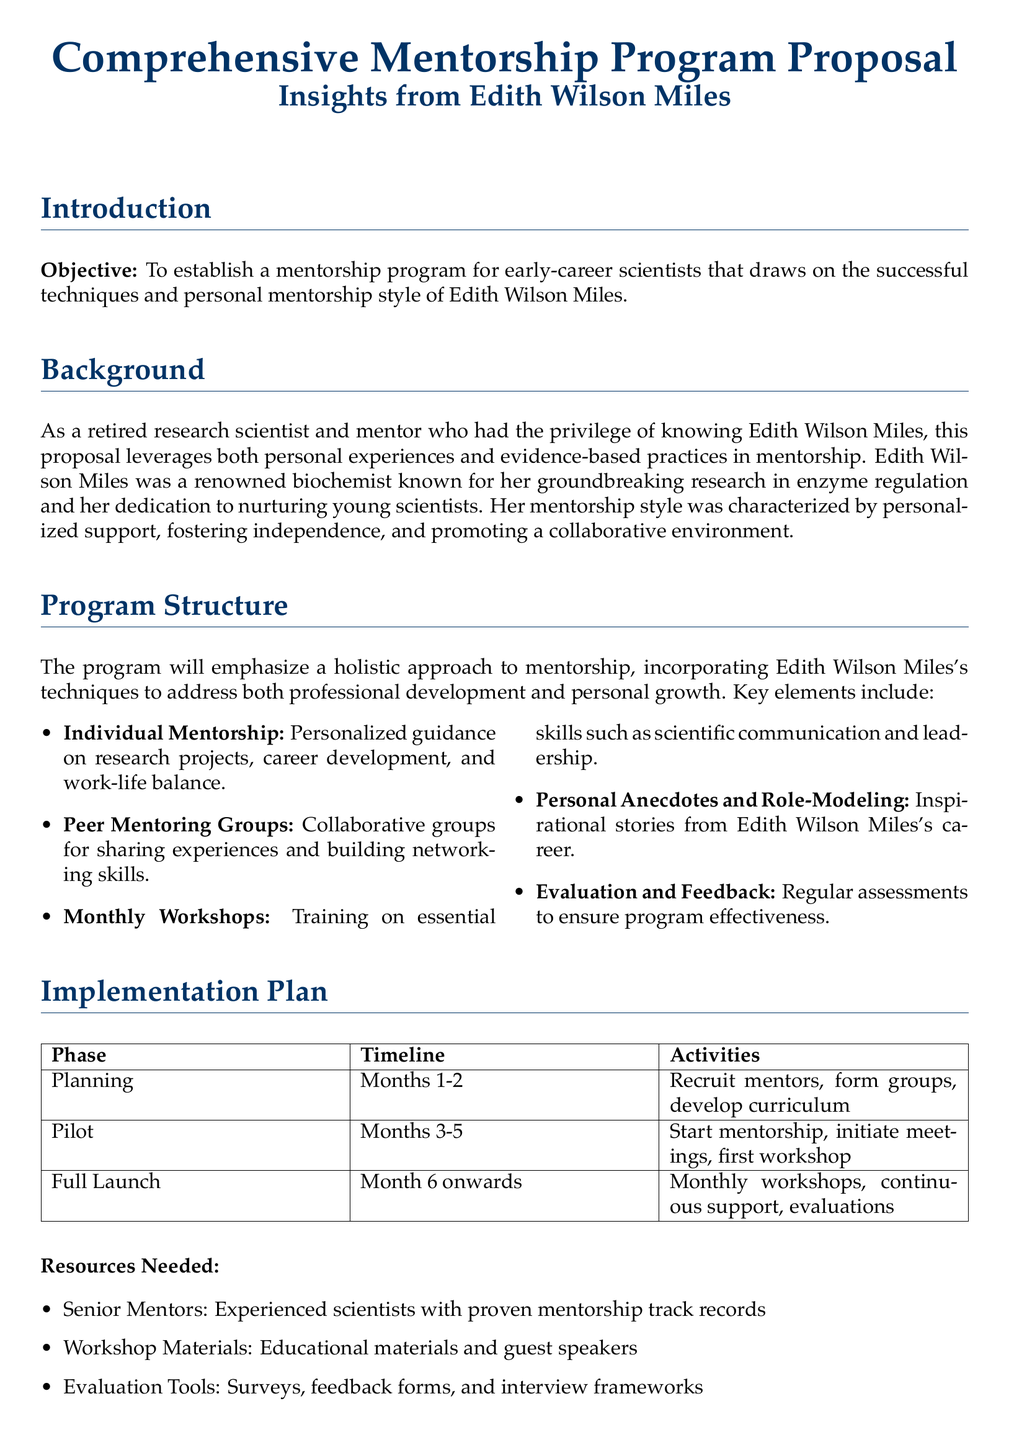What is the objective of the proposal? The objective is to establish a mentorship program for early-career scientists that draws on the successful techniques and personal mentorship style of Edith Wilson Miles.
Answer: Establish a mentorship program Who is the renowned biochemist mentioned in the proposal? The proposal refers to Edith Wilson Miles as a renowned biochemist known for her groundbreaking research.
Answer: Edith Wilson Miles How many key elements are mentioned in the program structure? The program structure lists five key elements that will be emphasized.
Answer: Five What is the timeline for the planning phase? The planning phase is set for Months 1-2 as detailed in the implementation plan.
Answer: Months 1-2 What type of groups will be formed under the mentorship program? Peer mentoring groups will be formed for sharing experiences and building networking skills.
Answer: Peer mentoring groups What is listed as a resource needed for the program? Senior mentors are identified as one of the resources needed for the program.
Answer: Senior mentors What is the main focus of the monthly workshops? The main focus of the workshops is training on essential skills such as scientific communication and leadership.
Answer: Essential skills What is the purpose of evaluation and feedback in the program? Evaluation and feedback are intended to ensure program effectiveness through regular assessments.
Answer: Ensure program effectiveness What style characterized Edith Wilson Miles's mentorship? Edith Wilson Miles's mentorship style was characterized by personalized support, fostering independence, and promoting a collaborative environment.
Answer: Personalized support 